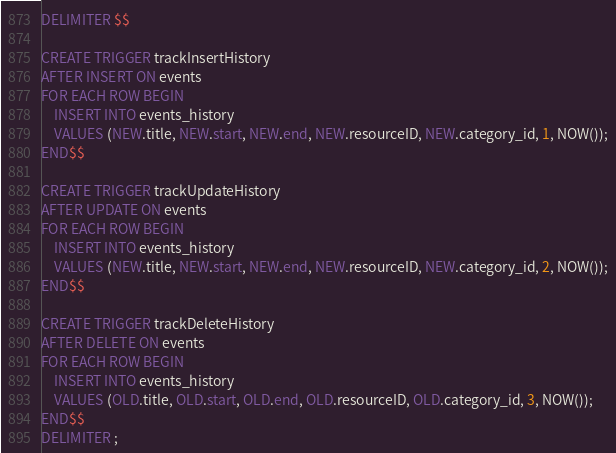<code> <loc_0><loc_0><loc_500><loc_500><_SQL_>DELIMITER $$

CREATE TRIGGER trackInsertHistory
AFTER INSERT ON events
FOR EACH ROW BEGIN
    INSERT INTO events_history
    VALUES (NEW.title, NEW.start, NEW.end, NEW.resourceID, NEW.category_id, 1, NOW());
END$$

CREATE TRIGGER trackUpdateHistory
AFTER UPDATE ON events
FOR EACH ROW BEGIN
    INSERT INTO events_history
    VALUES (NEW.title, NEW.start, NEW.end, NEW.resourceID, NEW.category_id, 2, NOW());
END$$

CREATE TRIGGER trackDeleteHistory
AFTER DELETE ON events
FOR EACH ROW BEGIN
    INSERT INTO events_history
    VALUES (OLD.title, OLD.start, OLD.end, OLD.resourceID, OLD.category_id, 3, NOW());
END$$
DELIMITER ;</code> 